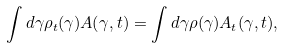Convert formula to latex. <formula><loc_0><loc_0><loc_500><loc_500>\int d \gamma \rho _ { t } ( \gamma ) A ( \gamma , t ) = \int d \gamma \rho ( \gamma ) A _ { t } ( \gamma , t ) ,</formula> 